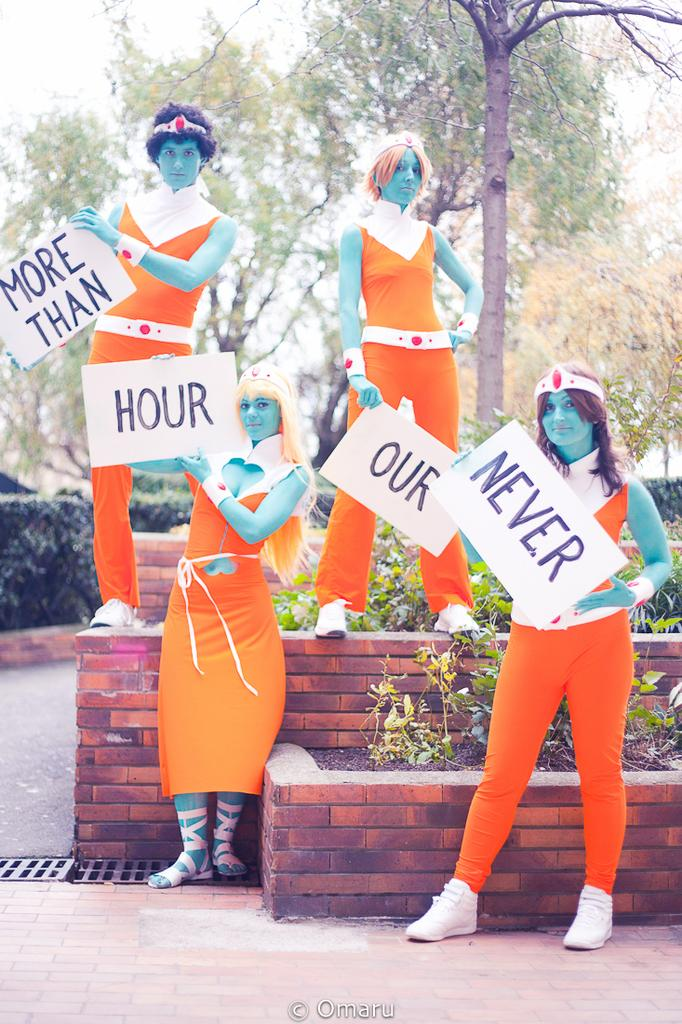What is happening in the image involving a group of people? There is a group of people in the image, and they are standing. What are the people holding in the image? The people in the image are holding posters. What can be seen in the background of the image? There are trees and the sky visible in the background of the image. How many dimes are scattered on the ground in the image? There are no dimes present in the image. Can you describe the type of fly that is buzzing around the people in the image? There are no flies present in the image. 